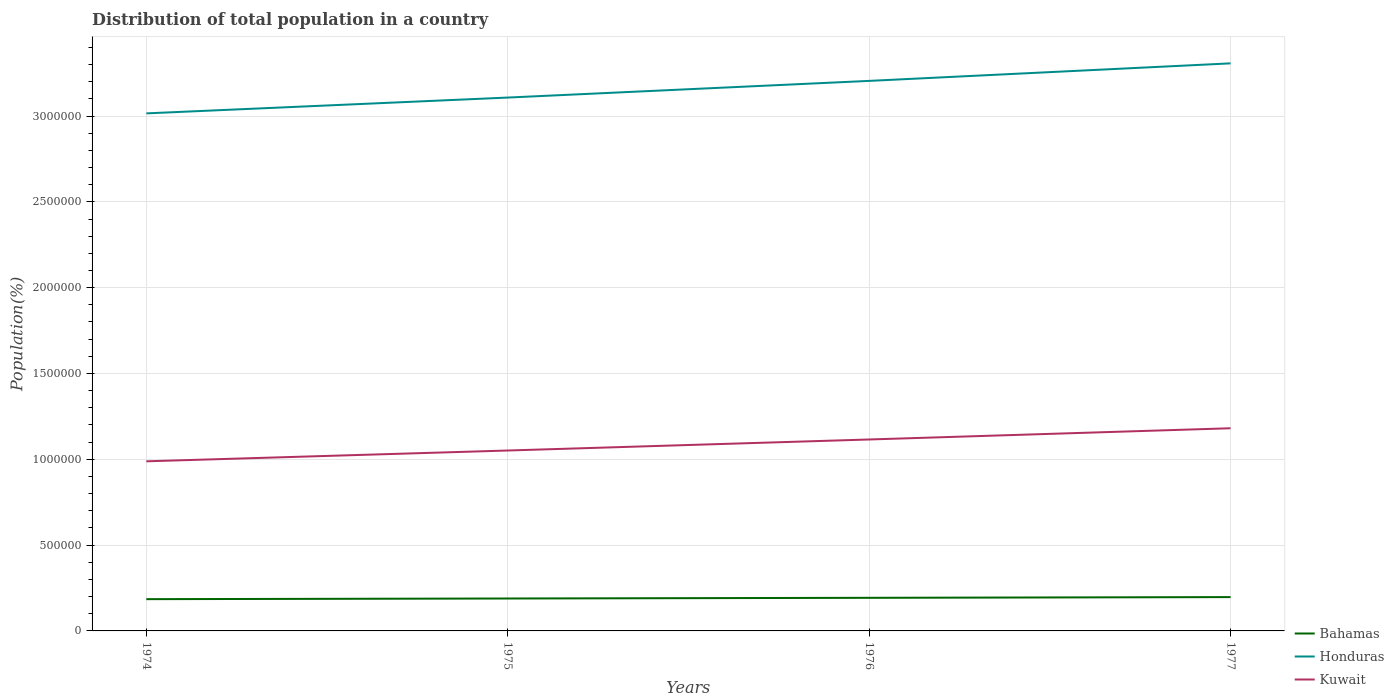Across all years, what is the maximum population of in Honduras?
Make the answer very short. 3.02e+06. In which year was the population of in Kuwait maximum?
Offer a terse response. 1974. What is the total population of in Honduras in the graph?
Make the answer very short. -1.02e+05. What is the difference between the highest and the second highest population of in Kuwait?
Offer a very short reply. 1.93e+05. Is the population of in Kuwait strictly greater than the population of in Bahamas over the years?
Give a very brief answer. No. How many lines are there?
Provide a short and direct response. 3. How many years are there in the graph?
Ensure brevity in your answer.  4. What is the difference between two consecutive major ticks on the Y-axis?
Offer a very short reply. 5.00e+05. Are the values on the major ticks of Y-axis written in scientific E-notation?
Your response must be concise. No. Does the graph contain any zero values?
Your answer should be very brief. No. Does the graph contain grids?
Provide a short and direct response. Yes. How many legend labels are there?
Ensure brevity in your answer.  3. How are the legend labels stacked?
Ensure brevity in your answer.  Vertical. What is the title of the graph?
Your answer should be very brief. Distribution of total population in a country. Does "Fragile and conflict affected situations" appear as one of the legend labels in the graph?
Ensure brevity in your answer.  No. What is the label or title of the Y-axis?
Your answer should be compact. Population(%). What is the Population(%) of Bahamas in 1974?
Your response must be concise. 1.85e+05. What is the Population(%) in Honduras in 1974?
Provide a succinct answer. 3.02e+06. What is the Population(%) in Kuwait in 1974?
Provide a succinct answer. 9.88e+05. What is the Population(%) of Bahamas in 1975?
Make the answer very short. 1.89e+05. What is the Population(%) in Honduras in 1975?
Give a very brief answer. 3.11e+06. What is the Population(%) in Kuwait in 1975?
Your response must be concise. 1.05e+06. What is the Population(%) of Bahamas in 1976?
Offer a very short reply. 1.93e+05. What is the Population(%) in Honduras in 1976?
Make the answer very short. 3.20e+06. What is the Population(%) of Kuwait in 1976?
Your answer should be compact. 1.12e+06. What is the Population(%) in Bahamas in 1977?
Ensure brevity in your answer.  1.97e+05. What is the Population(%) of Honduras in 1977?
Offer a terse response. 3.31e+06. What is the Population(%) of Kuwait in 1977?
Provide a succinct answer. 1.18e+06. Across all years, what is the maximum Population(%) of Bahamas?
Keep it short and to the point. 1.97e+05. Across all years, what is the maximum Population(%) in Honduras?
Offer a terse response. 3.31e+06. Across all years, what is the maximum Population(%) of Kuwait?
Provide a short and direct response. 1.18e+06. Across all years, what is the minimum Population(%) in Bahamas?
Your answer should be very brief. 1.85e+05. Across all years, what is the minimum Population(%) of Honduras?
Provide a short and direct response. 3.02e+06. Across all years, what is the minimum Population(%) in Kuwait?
Your answer should be compact. 9.88e+05. What is the total Population(%) of Bahamas in the graph?
Make the answer very short. 7.64e+05. What is the total Population(%) in Honduras in the graph?
Offer a very short reply. 1.26e+07. What is the total Population(%) in Kuwait in the graph?
Offer a very short reply. 4.34e+06. What is the difference between the Population(%) in Bahamas in 1974 and that in 1975?
Give a very brief answer. -3785. What is the difference between the Population(%) in Honduras in 1974 and that in 1975?
Your response must be concise. -9.21e+04. What is the difference between the Population(%) in Kuwait in 1974 and that in 1975?
Provide a succinct answer. -6.29e+04. What is the difference between the Population(%) of Bahamas in 1974 and that in 1976?
Your answer should be compact. -7808. What is the difference between the Population(%) in Honduras in 1974 and that in 1976?
Ensure brevity in your answer.  -1.89e+05. What is the difference between the Population(%) of Kuwait in 1974 and that in 1976?
Give a very brief answer. -1.27e+05. What is the difference between the Population(%) in Bahamas in 1974 and that in 1977?
Make the answer very short. -1.20e+04. What is the difference between the Population(%) in Honduras in 1974 and that in 1977?
Your answer should be compact. -2.91e+05. What is the difference between the Population(%) in Kuwait in 1974 and that in 1977?
Give a very brief answer. -1.93e+05. What is the difference between the Population(%) in Bahamas in 1975 and that in 1976?
Provide a short and direct response. -4023. What is the difference between the Population(%) in Honduras in 1975 and that in 1976?
Offer a very short reply. -9.71e+04. What is the difference between the Population(%) of Kuwait in 1975 and that in 1976?
Your answer should be very brief. -6.43e+04. What is the difference between the Population(%) in Bahamas in 1975 and that in 1977?
Ensure brevity in your answer.  -8236. What is the difference between the Population(%) of Honduras in 1975 and that in 1977?
Ensure brevity in your answer.  -1.99e+05. What is the difference between the Population(%) in Kuwait in 1975 and that in 1977?
Provide a succinct answer. -1.30e+05. What is the difference between the Population(%) in Bahamas in 1976 and that in 1977?
Your response must be concise. -4213. What is the difference between the Population(%) of Honduras in 1976 and that in 1977?
Your response must be concise. -1.02e+05. What is the difference between the Population(%) in Kuwait in 1976 and that in 1977?
Keep it short and to the point. -6.55e+04. What is the difference between the Population(%) of Bahamas in 1974 and the Population(%) of Honduras in 1975?
Provide a short and direct response. -2.92e+06. What is the difference between the Population(%) in Bahamas in 1974 and the Population(%) in Kuwait in 1975?
Offer a terse response. -8.66e+05. What is the difference between the Population(%) of Honduras in 1974 and the Population(%) of Kuwait in 1975?
Make the answer very short. 1.96e+06. What is the difference between the Population(%) of Bahamas in 1974 and the Population(%) of Honduras in 1976?
Make the answer very short. -3.02e+06. What is the difference between the Population(%) in Bahamas in 1974 and the Population(%) in Kuwait in 1976?
Give a very brief answer. -9.30e+05. What is the difference between the Population(%) of Honduras in 1974 and the Population(%) of Kuwait in 1976?
Provide a succinct answer. 1.90e+06. What is the difference between the Population(%) in Bahamas in 1974 and the Population(%) in Honduras in 1977?
Your answer should be compact. -3.12e+06. What is the difference between the Population(%) of Bahamas in 1974 and the Population(%) of Kuwait in 1977?
Ensure brevity in your answer.  -9.96e+05. What is the difference between the Population(%) in Honduras in 1974 and the Population(%) in Kuwait in 1977?
Provide a short and direct response. 1.83e+06. What is the difference between the Population(%) in Bahamas in 1975 and the Population(%) in Honduras in 1976?
Your answer should be compact. -3.02e+06. What is the difference between the Population(%) in Bahamas in 1975 and the Population(%) in Kuwait in 1976?
Your response must be concise. -9.27e+05. What is the difference between the Population(%) in Honduras in 1975 and the Population(%) in Kuwait in 1976?
Make the answer very short. 1.99e+06. What is the difference between the Population(%) of Bahamas in 1975 and the Population(%) of Honduras in 1977?
Make the answer very short. -3.12e+06. What is the difference between the Population(%) of Bahamas in 1975 and the Population(%) of Kuwait in 1977?
Give a very brief answer. -9.92e+05. What is the difference between the Population(%) of Honduras in 1975 and the Population(%) of Kuwait in 1977?
Give a very brief answer. 1.93e+06. What is the difference between the Population(%) in Bahamas in 1976 and the Population(%) in Honduras in 1977?
Make the answer very short. -3.11e+06. What is the difference between the Population(%) in Bahamas in 1976 and the Population(%) in Kuwait in 1977?
Provide a succinct answer. -9.88e+05. What is the difference between the Population(%) in Honduras in 1976 and the Population(%) in Kuwait in 1977?
Keep it short and to the point. 2.02e+06. What is the average Population(%) of Bahamas per year?
Keep it short and to the point. 1.91e+05. What is the average Population(%) of Honduras per year?
Ensure brevity in your answer.  3.16e+06. What is the average Population(%) in Kuwait per year?
Your response must be concise. 1.08e+06. In the year 1974, what is the difference between the Population(%) in Bahamas and Population(%) in Honduras?
Ensure brevity in your answer.  -2.83e+06. In the year 1974, what is the difference between the Population(%) of Bahamas and Population(%) of Kuwait?
Ensure brevity in your answer.  -8.03e+05. In the year 1974, what is the difference between the Population(%) of Honduras and Population(%) of Kuwait?
Provide a short and direct response. 2.03e+06. In the year 1975, what is the difference between the Population(%) of Bahamas and Population(%) of Honduras?
Your response must be concise. -2.92e+06. In the year 1975, what is the difference between the Population(%) of Bahamas and Population(%) of Kuwait?
Your answer should be compact. -8.62e+05. In the year 1975, what is the difference between the Population(%) of Honduras and Population(%) of Kuwait?
Provide a short and direct response. 2.06e+06. In the year 1976, what is the difference between the Population(%) of Bahamas and Population(%) of Honduras?
Your answer should be very brief. -3.01e+06. In the year 1976, what is the difference between the Population(%) in Bahamas and Population(%) in Kuwait?
Your answer should be very brief. -9.23e+05. In the year 1976, what is the difference between the Population(%) of Honduras and Population(%) of Kuwait?
Keep it short and to the point. 2.09e+06. In the year 1977, what is the difference between the Population(%) in Bahamas and Population(%) in Honduras?
Offer a very short reply. -3.11e+06. In the year 1977, what is the difference between the Population(%) in Bahamas and Population(%) in Kuwait?
Provide a short and direct response. -9.84e+05. In the year 1977, what is the difference between the Population(%) of Honduras and Population(%) of Kuwait?
Your response must be concise. 2.13e+06. What is the ratio of the Population(%) of Honduras in 1974 to that in 1975?
Offer a terse response. 0.97. What is the ratio of the Population(%) of Kuwait in 1974 to that in 1975?
Give a very brief answer. 0.94. What is the ratio of the Population(%) of Bahamas in 1974 to that in 1976?
Offer a terse response. 0.96. What is the ratio of the Population(%) of Honduras in 1974 to that in 1976?
Provide a short and direct response. 0.94. What is the ratio of the Population(%) in Kuwait in 1974 to that in 1976?
Provide a short and direct response. 0.89. What is the ratio of the Population(%) in Bahamas in 1974 to that in 1977?
Give a very brief answer. 0.94. What is the ratio of the Population(%) in Honduras in 1974 to that in 1977?
Provide a short and direct response. 0.91. What is the ratio of the Population(%) of Kuwait in 1974 to that in 1977?
Your answer should be very brief. 0.84. What is the ratio of the Population(%) of Bahamas in 1975 to that in 1976?
Your response must be concise. 0.98. What is the ratio of the Population(%) in Honduras in 1975 to that in 1976?
Provide a short and direct response. 0.97. What is the ratio of the Population(%) in Kuwait in 1975 to that in 1976?
Offer a very short reply. 0.94. What is the ratio of the Population(%) of Bahamas in 1975 to that in 1977?
Give a very brief answer. 0.96. What is the ratio of the Population(%) in Honduras in 1975 to that in 1977?
Your answer should be very brief. 0.94. What is the ratio of the Population(%) in Kuwait in 1975 to that in 1977?
Offer a very short reply. 0.89. What is the ratio of the Population(%) in Bahamas in 1976 to that in 1977?
Make the answer very short. 0.98. What is the ratio of the Population(%) of Honduras in 1976 to that in 1977?
Give a very brief answer. 0.97. What is the ratio of the Population(%) in Kuwait in 1976 to that in 1977?
Your answer should be compact. 0.94. What is the difference between the highest and the second highest Population(%) of Bahamas?
Your response must be concise. 4213. What is the difference between the highest and the second highest Population(%) of Honduras?
Ensure brevity in your answer.  1.02e+05. What is the difference between the highest and the second highest Population(%) of Kuwait?
Keep it short and to the point. 6.55e+04. What is the difference between the highest and the lowest Population(%) in Bahamas?
Keep it short and to the point. 1.20e+04. What is the difference between the highest and the lowest Population(%) of Honduras?
Offer a terse response. 2.91e+05. What is the difference between the highest and the lowest Population(%) in Kuwait?
Offer a terse response. 1.93e+05. 